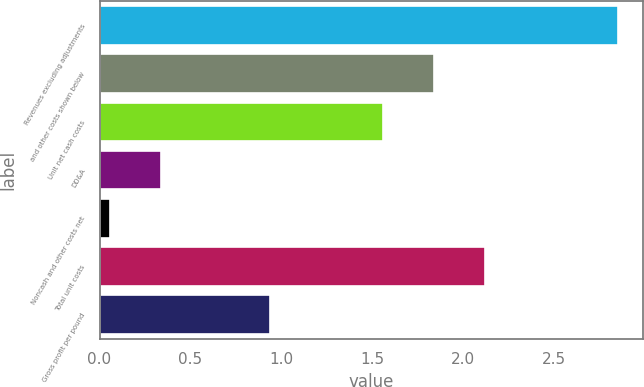Convert chart. <chart><loc_0><loc_0><loc_500><loc_500><bar_chart><fcel>Revenues excluding adjustments<fcel>and other costs shown below<fcel>Unit net cash costs<fcel>DD&A<fcel>Noncash and other costs net<fcel>Total unit costs<fcel>Gross profit per pound<nl><fcel>2.85<fcel>1.84<fcel>1.56<fcel>0.34<fcel>0.06<fcel>2.12<fcel>0.94<nl></chart> 